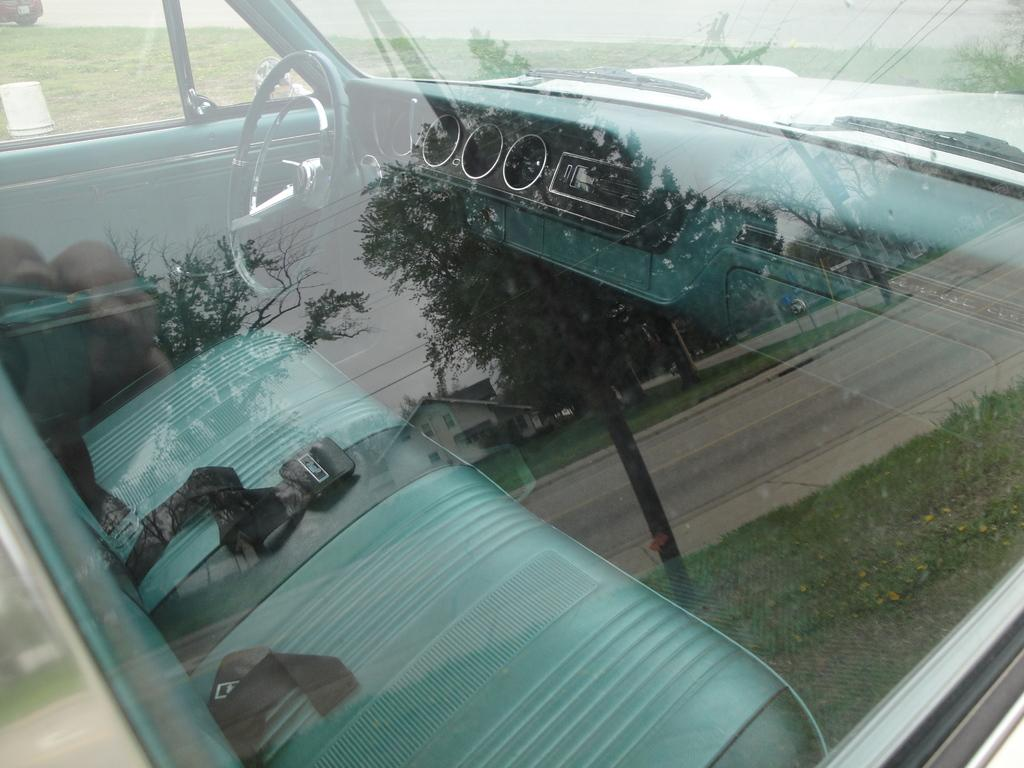What type of vehicle is in the image? There is a vehicle in the image, but the specific type is not mentioned. What type of terrain is visible in the image? There is grass and trees in the image, which suggests a natural environment. What type of infrastructure is present in the image? There is a road, houses, poles, and a board in the image, which suggests a residential or urban area. What is visible in the sky in the image? The sky is visible in the image, but no specific details about the weather or time of day are mentioned. What is the name of the train that is passing by in the image? There is no train present in the image, so there is no name to provide. How much has the growth of the trees in the image increased since last year? The image does not provide any information about the growth of the trees or any time frame, so it is impossible to answer this question. 